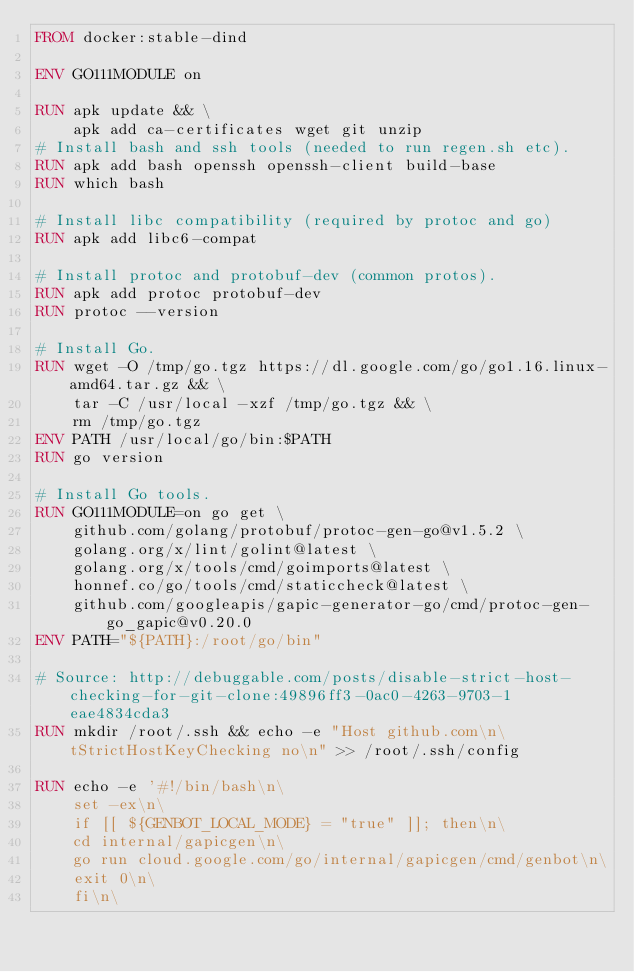<code> <loc_0><loc_0><loc_500><loc_500><_Dockerfile_>FROM docker:stable-dind

ENV GO111MODULE on

RUN apk update && \
    apk add ca-certificates wget git unzip
# Install bash and ssh tools (needed to run regen.sh etc).
RUN apk add bash openssh openssh-client build-base
RUN which bash

# Install libc compatibility (required by protoc and go)
RUN apk add libc6-compat

# Install protoc and protobuf-dev (common protos).
RUN apk add protoc protobuf-dev
RUN protoc --version

# Install Go.
RUN wget -O /tmp/go.tgz https://dl.google.com/go/go1.16.linux-amd64.tar.gz && \
    tar -C /usr/local -xzf /tmp/go.tgz && \
    rm /tmp/go.tgz
ENV PATH /usr/local/go/bin:$PATH
RUN go version

# Install Go tools.
RUN GO111MODULE=on go get \
    github.com/golang/protobuf/protoc-gen-go@v1.5.2 \
    golang.org/x/lint/golint@latest \
    golang.org/x/tools/cmd/goimports@latest \
    honnef.co/go/tools/cmd/staticcheck@latest \
    github.com/googleapis/gapic-generator-go/cmd/protoc-gen-go_gapic@v0.20.0
ENV PATH="${PATH}:/root/go/bin"

# Source: http://debuggable.com/posts/disable-strict-host-checking-for-git-clone:49896ff3-0ac0-4263-9703-1eae4834cda3
RUN mkdir /root/.ssh && echo -e "Host github.com\n\tStrictHostKeyChecking no\n" >> /root/.ssh/config

RUN echo -e '#!/bin/bash\n\
    set -ex\n\
    if [[ ${GENBOT_LOCAL_MODE} = "true" ]]; then\n\
    cd internal/gapicgen\n\
    go run cloud.google.com/go/internal/gapicgen/cmd/genbot\n\
    exit 0\n\
    fi\n\</code> 